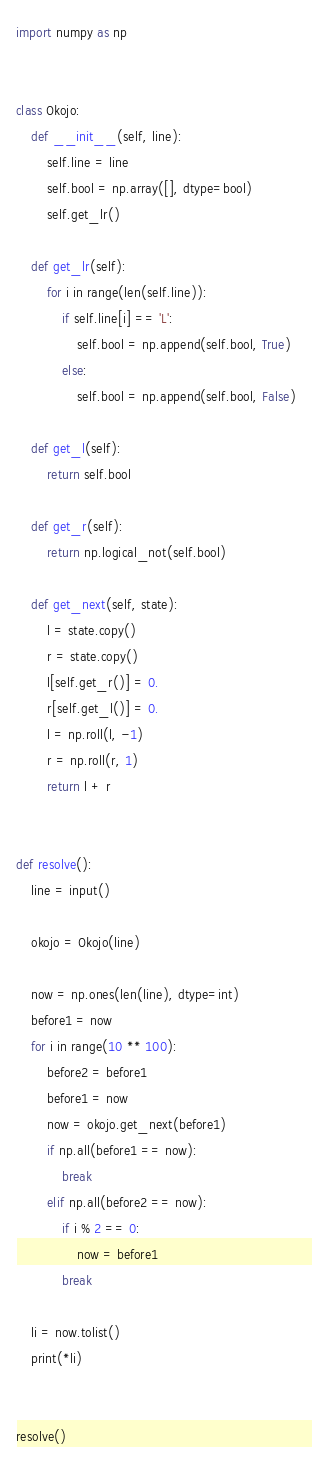Convert code to text. <code><loc_0><loc_0><loc_500><loc_500><_Python_>import numpy as np


class Okojo:
    def __init__(self, line):
        self.line = line
        self.bool = np.array([], dtype=bool)
        self.get_lr()

    def get_lr(self):
        for i in range(len(self.line)):
            if self.line[i] == 'L':
                self.bool = np.append(self.bool, True)
            else:
                self.bool = np.append(self.bool, False)

    def get_l(self):
        return self.bool

    def get_r(self):
        return np.logical_not(self.bool)

    def get_next(self, state):
        l = state.copy()
        r = state.copy()
        l[self.get_r()] = 0.
        r[self.get_l()] = 0.
        l = np.roll(l, -1)
        r = np.roll(r, 1)
        return l + r


def resolve():
    line = input()

    okojo = Okojo(line)

    now = np.ones(len(line), dtype=int)
    before1 = now
    for i in range(10 ** 100):
        before2 = before1
        before1 = now
        now = okojo.get_next(before1)
        if np.all(before1 == now):
            break
        elif np.all(before2 == now):
            if i % 2 == 0:
                now = before1
            break

    li = now.tolist()
    print(*li)


resolve()</code> 